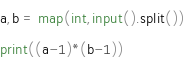Convert code to text. <code><loc_0><loc_0><loc_500><loc_500><_Python_>a,b = map(int,input().split())
print((a-1)*(b-1))</code> 